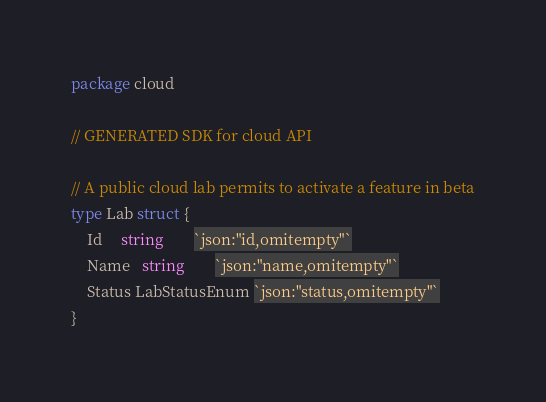Convert code to text. <code><loc_0><loc_0><loc_500><loc_500><_Go_>package cloud

// GENERATED SDK for cloud API

// A public cloud lab permits to activate a feature in beta
type Lab struct {
	Id     string        `json:"id,omitempty"`
	Name   string        `json:"name,omitempty"`
	Status LabStatusEnum `json:"status,omitempty"`
}
</code> 